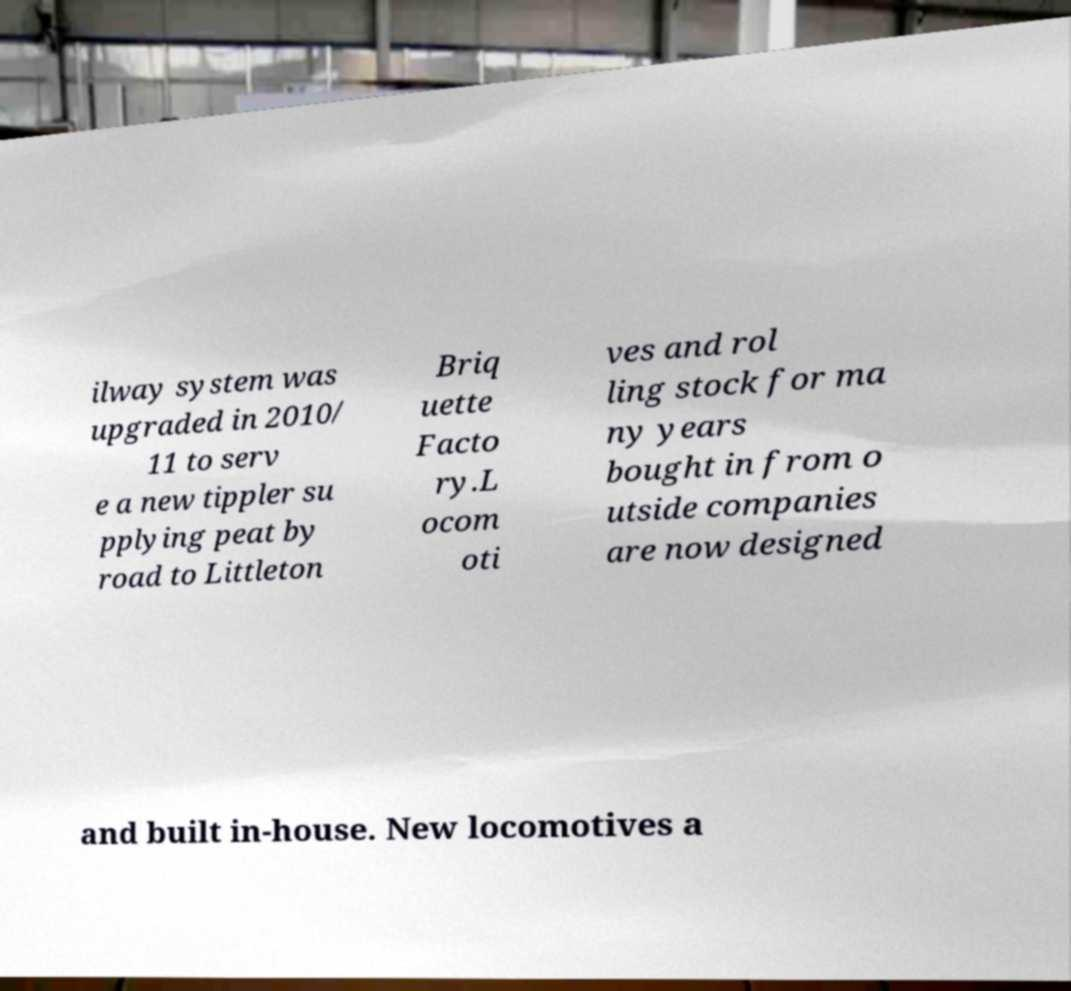There's text embedded in this image that I need extracted. Can you transcribe it verbatim? ilway system was upgraded in 2010/ 11 to serv e a new tippler su pplying peat by road to Littleton Briq uette Facto ry.L ocom oti ves and rol ling stock for ma ny years bought in from o utside companies are now designed and built in-house. New locomotives a 